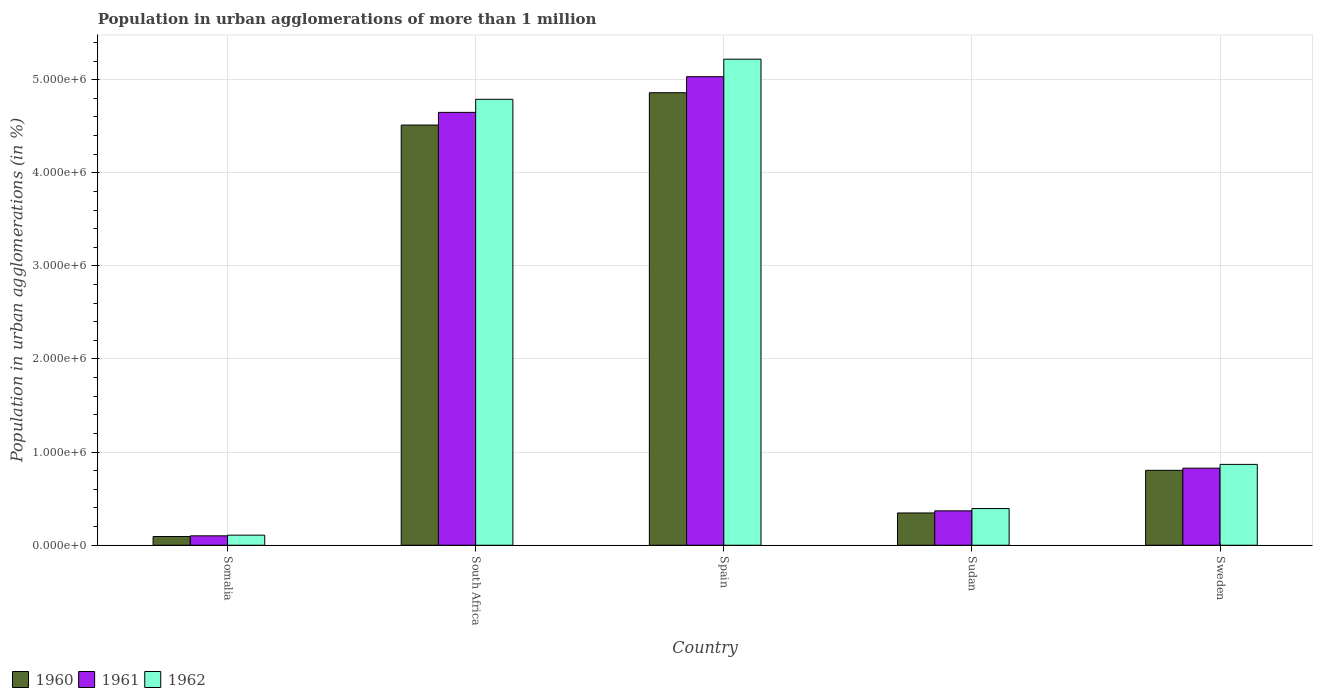How many different coloured bars are there?
Your answer should be compact. 3. Are the number of bars on each tick of the X-axis equal?
Your answer should be very brief. Yes. How many bars are there on the 1st tick from the left?
Provide a short and direct response. 3. What is the label of the 1st group of bars from the left?
Make the answer very short. Somalia. In how many cases, is the number of bars for a given country not equal to the number of legend labels?
Offer a very short reply. 0. What is the population in urban agglomerations in 1962 in South Africa?
Offer a terse response. 4.79e+06. Across all countries, what is the maximum population in urban agglomerations in 1962?
Provide a succinct answer. 5.22e+06. Across all countries, what is the minimum population in urban agglomerations in 1960?
Your response must be concise. 9.39e+04. In which country was the population in urban agglomerations in 1962 minimum?
Offer a terse response. Somalia. What is the total population in urban agglomerations in 1960 in the graph?
Keep it short and to the point. 1.06e+07. What is the difference between the population in urban agglomerations in 1962 in Somalia and that in Spain?
Offer a terse response. -5.11e+06. What is the difference between the population in urban agglomerations in 1962 in Spain and the population in urban agglomerations in 1961 in Sudan?
Make the answer very short. 4.85e+06. What is the average population in urban agglomerations in 1961 per country?
Ensure brevity in your answer.  2.20e+06. What is the difference between the population in urban agglomerations of/in 1960 and population in urban agglomerations of/in 1961 in Spain?
Offer a terse response. -1.72e+05. In how many countries, is the population in urban agglomerations in 1960 greater than 4800000 %?
Make the answer very short. 1. What is the ratio of the population in urban agglomerations in 1960 in Sudan to that in Sweden?
Give a very brief answer. 0.43. What is the difference between the highest and the second highest population in urban agglomerations in 1960?
Provide a succinct answer. -3.47e+05. What is the difference between the highest and the lowest population in urban agglomerations in 1960?
Your answer should be compact. 4.77e+06. In how many countries, is the population in urban agglomerations in 1961 greater than the average population in urban agglomerations in 1961 taken over all countries?
Your answer should be very brief. 2. Is the sum of the population in urban agglomerations in 1960 in South Africa and Spain greater than the maximum population in urban agglomerations in 1962 across all countries?
Your response must be concise. Yes. What does the 3rd bar from the left in South Africa represents?
Keep it short and to the point. 1962. What does the 3rd bar from the right in Sweden represents?
Keep it short and to the point. 1960. Is it the case that in every country, the sum of the population in urban agglomerations in 1962 and population in urban agglomerations in 1961 is greater than the population in urban agglomerations in 1960?
Make the answer very short. Yes. How many bars are there?
Your response must be concise. 15. How many countries are there in the graph?
Your answer should be compact. 5. Does the graph contain any zero values?
Your answer should be very brief. No. Where does the legend appear in the graph?
Give a very brief answer. Bottom left. How are the legend labels stacked?
Ensure brevity in your answer.  Horizontal. What is the title of the graph?
Give a very brief answer. Population in urban agglomerations of more than 1 million. What is the label or title of the X-axis?
Offer a terse response. Country. What is the label or title of the Y-axis?
Make the answer very short. Population in urban agglomerations (in %). What is the Population in urban agglomerations (in %) in 1960 in Somalia?
Your answer should be compact. 9.39e+04. What is the Population in urban agglomerations (in %) of 1961 in Somalia?
Provide a succinct answer. 1.01e+05. What is the Population in urban agglomerations (in %) in 1962 in Somalia?
Provide a succinct answer. 1.08e+05. What is the Population in urban agglomerations (in %) of 1960 in South Africa?
Offer a terse response. 4.51e+06. What is the Population in urban agglomerations (in %) of 1961 in South Africa?
Give a very brief answer. 4.65e+06. What is the Population in urban agglomerations (in %) in 1962 in South Africa?
Offer a very short reply. 4.79e+06. What is the Population in urban agglomerations (in %) in 1960 in Spain?
Your response must be concise. 4.86e+06. What is the Population in urban agglomerations (in %) of 1961 in Spain?
Your answer should be very brief. 5.03e+06. What is the Population in urban agglomerations (in %) of 1962 in Spain?
Your answer should be compact. 5.22e+06. What is the Population in urban agglomerations (in %) in 1960 in Sudan?
Provide a short and direct response. 3.47e+05. What is the Population in urban agglomerations (in %) in 1961 in Sudan?
Your answer should be very brief. 3.69e+05. What is the Population in urban agglomerations (in %) of 1962 in Sudan?
Offer a very short reply. 3.94e+05. What is the Population in urban agglomerations (in %) in 1960 in Sweden?
Give a very brief answer. 8.05e+05. What is the Population in urban agglomerations (in %) of 1961 in Sweden?
Offer a terse response. 8.27e+05. What is the Population in urban agglomerations (in %) in 1962 in Sweden?
Make the answer very short. 8.68e+05. Across all countries, what is the maximum Population in urban agglomerations (in %) in 1960?
Your response must be concise. 4.86e+06. Across all countries, what is the maximum Population in urban agglomerations (in %) in 1961?
Your answer should be very brief. 5.03e+06. Across all countries, what is the maximum Population in urban agglomerations (in %) in 1962?
Your answer should be compact. 5.22e+06. Across all countries, what is the minimum Population in urban agglomerations (in %) of 1960?
Your answer should be very brief. 9.39e+04. Across all countries, what is the minimum Population in urban agglomerations (in %) of 1961?
Your response must be concise. 1.01e+05. Across all countries, what is the minimum Population in urban agglomerations (in %) of 1962?
Keep it short and to the point. 1.08e+05. What is the total Population in urban agglomerations (in %) in 1960 in the graph?
Offer a very short reply. 1.06e+07. What is the total Population in urban agglomerations (in %) in 1961 in the graph?
Offer a terse response. 1.10e+07. What is the total Population in urban agglomerations (in %) of 1962 in the graph?
Ensure brevity in your answer.  1.14e+07. What is the difference between the Population in urban agglomerations (in %) of 1960 in Somalia and that in South Africa?
Make the answer very short. -4.42e+06. What is the difference between the Population in urban agglomerations (in %) in 1961 in Somalia and that in South Africa?
Ensure brevity in your answer.  -4.55e+06. What is the difference between the Population in urban agglomerations (in %) of 1962 in Somalia and that in South Africa?
Make the answer very short. -4.68e+06. What is the difference between the Population in urban agglomerations (in %) in 1960 in Somalia and that in Spain?
Offer a terse response. -4.77e+06. What is the difference between the Population in urban agglomerations (in %) in 1961 in Somalia and that in Spain?
Provide a succinct answer. -4.93e+06. What is the difference between the Population in urban agglomerations (in %) of 1962 in Somalia and that in Spain?
Give a very brief answer. -5.11e+06. What is the difference between the Population in urban agglomerations (in %) of 1960 in Somalia and that in Sudan?
Offer a terse response. -2.53e+05. What is the difference between the Population in urban agglomerations (in %) in 1961 in Somalia and that in Sudan?
Your response must be concise. -2.69e+05. What is the difference between the Population in urban agglomerations (in %) of 1962 in Somalia and that in Sudan?
Your response must be concise. -2.86e+05. What is the difference between the Population in urban agglomerations (in %) of 1960 in Somalia and that in Sweden?
Your response must be concise. -7.11e+05. What is the difference between the Population in urban agglomerations (in %) in 1961 in Somalia and that in Sweden?
Offer a very short reply. -7.27e+05. What is the difference between the Population in urban agglomerations (in %) of 1962 in Somalia and that in Sweden?
Your answer should be very brief. -7.60e+05. What is the difference between the Population in urban agglomerations (in %) in 1960 in South Africa and that in Spain?
Offer a terse response. -3.47e+05. What is the difference between the Population in urban agglomerations (in %) of 1961 in South Africa and that in Spain?
Keep it short and to the point. -3.83e+05. What is the difference between the Population in urban agglomerations (in %) of 1962 in South Africa and that in Spain?
Give a very brief answer. -4.31e+05. What is the difference between the Population in urban agglomerations (in %) in 1960 in South Africa and that in Sudan?
Your response must be concise. 4.17e+06. What is the difference between the Population in urban agglomerations (in %) of 1961 in South Africa and that in Sudan?
Your answer should be compact. 4.28e+06. What is the difference between the Population in urban agglomerations (in %) in 1962 in South Africa and that in Sudan?
Give a very brief answer. 4.39e+06. What is the difference between the Population in urban agglomerations (in %) of 1960 in South Africa and that in Sweden?
Make the answer very short. 3.71e+06. What is the difference between the Population in urban agglomerations (in %) in 1961 in South Africa and that in Sweden?
Your answer should be compact. 3.82e+06. What is the difference between the Population in urban agglomerations (in %) of 1962 in South Africa and that in Sweden?
Provide a short and direct response. 3.92e+06. What is the difference between the Population in urban agglomerations (in %) in 1960 in Spain and that in Sudan?
Provide a short and direct response. 4.51e+06. What is the difference between the Population in urban agglomerations (in %) in 1961 in Spain and that in Sudan?
Offer a terse response. 4.66e+06. What is the difference between the Population in urban agglomerations (in %) of 1962 in Spain and that in Sudan?
Your answer should be compact. 4.83e+06. What is the difference between the Population in urban agglomerations (in %) in 1960 in Spain and that in Sweden?
Offer a terse response. 4.05e+06. What is the difference between the Population in urban agglomerations (in %) of 1961 in Spain and that in Sweden?
Provide a short and direct response. 4.20e+06. What is the difference between the Population in urban agglomerations (in %) of 1962 in Spain and that in Sweden?
Make the answer very short. 4.35e+06. What is the difference between the Population in urban agglomerations (in %) in 1960 in Sudan and that in Sweden?
Keep it short and to the point. -4.58e+05. What is the difference between the Population in urban agglomerations (in %) in 1961 in Sudan and that in Sweden?
Your answer should be compact. -4.58e+05. What is the difference between the Population in urban agglomerations (in %) in 1962 in Sudan and that in Sweden?
Your answer should be very brief. -4.74e+05. What is the difference between the Population in urban agglomerations (in %) in 1960 in Somalia and the Population in urban agglomerations (in %) in 1961 in South Africa?
Your answer should be very brief. -4.55e+06. What is the difference between the Population in urban agglomerations (in %) of 1960 in Somalia and the Population in urban agglomerations (in %) of 1962 in South Africa?
Provide a short and direct response. -4.69e+06. What is the difference between the Population in urban agglomerations (in %) of 1961 in Somalia and the Population in urban agglomerations (in %) of 1962 in South Africa?
Provide a short and direct response. -4.69e+06. What is the difference between the Population in urban agglomerations (in %) in 1960 in Somalia and the Population in urban agglomerations (in %) in 1961 in Spain?
Your response must be concise. -4.94e+06. What is the difference between the Population in urban agglomerations (in %) of 1960 in Somalia and the Population in urban agglomerations (in %) of 1962 in Spain?
Provide a succinct answer. -5.13e+06. What is the difference between the Population in urban agglomerations (in %) of 1961 in Somalia and the Population in urban agglomerations (in %) of 1962 in Spain?
Your answer should be very brief. -5.12e+06. What is the difference between the Population in urban agglomerations (in %) of 1960 in Somalia and the Population in urban agglomerations (in %) of 1961 in Sudan?
Ensure brevity in your answer.  -2.76e+05. What is the difference between the Population in urban agglomerations (in %) in 1960 in Somalia and the Population in urban agglomerations (in %) in 1962 in Sudan?
Offer a very short reply. -3.00e+05. What is the difference between the Population in urban agglomerations (in %) of 1961 in Somalia and the Population in urban agglomerations (in %) of 1962 in Sudan?
Make the answer very short. -2.93e+05. What is the difference between the Population in urban agglomerations (in %) of 1960 in Somalia and the Population in urban agglomerations (in %) of 1961 in Sweden?
Offer a very short reply. -7.34e+05. What is the difference between the Population in urban agglomerations (in %) in 1960 in Somalia and the Population in urban agglomerations (in %) in 1962 in Sweden?
Offer a very short reply. -7.74e+05. What is the difference between the Population in urban agglomerations (in %) in 1961 in Somalia and the Population in urban agglomerations (in %) in 1962 in Sweden?
Offer a terse response. -7.67e+05. What is the difference between the Population in urban agglomerations (in %) of 1960 in South Africa and the Population in urban agglomerations (in %) of 1961 in Spain?
Provide a short and direct response. -5.19e+05. What is the difference between the Population in urban agglomerations (in %) in 1960 in South Africa and the Population in urban agglomerations (in %) in 1962 in Spain?
Your answer should be compact. -7.07e+05. What is the difference between the Population in urban agglomerations (in %) of 1961 in South Africa and the Population in urban agglomerations (in %) of 1962 in Spain?
Your answer should be compact. -5.71e+05. What is the difference between the Population in urban agglomerations (in %) of 1960 in South Africa and the Population in urban agglomerations (in %) of 1961 in Sudan?
Offer a very short reply. 4.14e+06. What is the difference between the Population in urban agglomerations (in %) in 1960 in South Africa and the Population in urban agglomerations (in %) in 1962 in Sudan?
Your answer should be compact. 4.12e+06. What is the difference between the Population in urban agglomerations (in %) of 1961 in South Africa and the Population in urban agglomerations (in %) of 1962 in Sudan?
Give a very brief answer. 4.25e+06. What is the difference between the Population in urban agglomerations (in %) of 1960 in South Africa and the Population in urban agglomerations (in %) of 1961 in Sweden?
Your answer should be compact. 3.68e+06. What is the difference between the Population in urban agglomerations (in %) in 1960 in South Africa and the Population in urban agglomerations (in %) in 1962 in Sweden?
Offer a very short reply. 3.64e+06. What is the difference between the Population in urban agglomerations (in %) in 1961 in South Africa and the Population in urban agglomerations (in %) in 1962 in Sweden?
Your answer should be compact. 3.78e+06. What is the difference between the Population in urban agglomerations (in %) in 1960 in Spain and the Population in urban agglomerations (in %) in 1961 in Sudan?
Your response must be concise. 4.49e+06. What is the difference between the Population in urban agglomerations (in %) of 1960 in Spain and the Population in urban agglomerations (in %) of 1962 in Sudan?
Your response must be concise. 4.47e+06. What is the difference between the Population in urban agglomerations (in %) of 1961 in Spain and the Population in urban agglomerations (in %) of 1962 in Sudan?
Provide a short and direct response. 4.64e+06. What is the difference between the Population in urban agglomerations (in %) in 1960 in Spain and the Population in urban agglomerations (in %) in 1961 in Sweden?
Offer a very short reply. 4.03e+06. What is the difference between the Population in urban agglomerations (in %) in 1960 in Spain and the Population in urban agglomerations (in %) in 1962 in Sweden?
Offer a terse response. 3.99e+06. What is the difference between the Population in urban agglomerations (in %) in 1961 in Spain and the Population in urban agglomerations (in %) in 1962 in Sweden?
Offer a very short reply. 4.16e+06. What is the difference between the Population in urban agglomerations (in %) in 1960 in Sudan and the Population in urban agglomerations (in %) in 1961 in Sweden?
Ensure brevity in your answer.  -4.81e+05. What is the difference between the Population in urban agglomerations (in %) in 1960 in Sudan and the Population in urban agglomerations (in %) in 1962 in Sweden?
Your response must be concise. -5.22e+05. What is the difference between the Population in urban agglomerations (in %) in 1961 in Sudan and the Population in urban agglomerations (in %) in 1962 in Sweden?
Provide a short and direct response. -4.99e+05. What is the average Population in urban agglomerations (in %) of 1960 per country?
Offer a very short reply. 2.12e+06. What is the average Population in urban agglomerations (in %) of 1961 per country?
Keep it short and to the point. 2.20e+06. What is the average Population in urban agglomerations (in %) in 1962 per country?
Keep it short and to the point. 2.28e+06. What is the difference between the Population in urban agglomerations (in %) in 1960 and Population in urban agglomerations (in %) in 1961 in Somalia?
Ensure brevity in your answer.  -6956. What is the difference between the Population in urban agglomerations (in %) in 1960 and Population in urban agglomerations (in %) in 1962 in Somalia?
Ensure brevity in your answer.  -1.44e+04. What is the difference between the Population in urban agglomerations (in %) in 1961 and Population in urban agglomerations (in %) in 1962 in Somalia?
Keep it short and to the point. -7482. What is the difference between the Population in urban agglomerations (in %) in 1960 and Population in urban agglomerations (in %) in 1961 in South Africa?
Offer a terse response. -1.36e+05. What is the difference between the Population in urban agglomerations (in %) of 1960 and Population in urban agglomerations (in %) of 1962 in South Africa?
Provide a short and direct response. -2.76e+05. What is the difference between the Population in urban agglomerations (in %) in 1961 and Population in urban agglomerations (in %) in 1962 in South Africa?
Keep it short and to the point. -1.40e+05. What is the difference between the Population in urban agglomerations (in %) in 1960 and Population in urban agglomerations (in %) in 1961 in Spain?
Offer a terse response. -1.72e+05. What is the difference between the Population in urban agglomerations (in %) of 1960 and Population in urban agglomerations (in %) of 1962 in Spain?
Your answer should be compact. -3.60e+05. What is the difference between the Population in urban agglomerations (in %) in 1961 and Population in urban agglomerations (in %) in 1962 in Spain?
Your answer should be compact. -1.88e+05. What is the difference between the Population in urban agglomerations (in %) of 1960 and Population in urban agglomerations (in %) of 1961 in Sudan?
Your answer should be very brief. -2.29e+04. What is the difference between the Population in urban agglomerations (in %) of 1960 and Population in urban agglomerations (in %) of 1962 in Sudan?
Make the answer very short. -4.73e+04. What is the difference between the Population in urban agglomerations (in %) of 1961 and Population in urban agglomerations (in %) of 1962 in Sudan?
Provide a succinct answer. -2.44e+04. What is the difference between the Population in urban agglomerations (in %) in 1960 and Population in urban agglomerations (in %) in 1961 in Sweden?
Make the answer very short. -2.29e+04. What is the difference between the Population in urban agglomerations (in %) in 1960 and Population in urban agglomerations (in %) in 1962 in Sweden?
Keep it short and to the point. -6.36e+04. What is the difference between the Population in urban agglomerations (in %) of 1961 and Population in urban agglomerations (in %) of 1962 in Sweden?
Your response must be concise. -4.07e+04. What is the ratio of the Population in urban agglomerations (in %) in 1960 in Somalia to that in South Africa?
Provide a short and direct response. 0.02. What is the ratio of the Population in urban agglomerations (in %) of 1961 in Somalia to that in South Africa?
Offer a very short reply. 0.02. What is the ratio of the Population in urban agglomerations (in %) in 1962 in Somalia to that in South Africa?
Your answer should be compact. 0.02. What is the ratio of the Population in urban agglomerations (in %) of 1960 in Somalia to that in Spain?
Give a very brief answer. 0.02. What is the ratio of the Population in urban agglomerations (in %) of 1962 in Somalia to that in Spain?
Your answer should be compact. 0.02. What is the ratio of the Population in urban agglomerations (in %) of 1960 in Somalia to that in Sudan?
Make the answer very short. 0.27. What is the ratio of the Population in urban agglomerations (in %) of 1961 in Somalia to that in Sudan?
Offer a terse response. 0.27. What is the ratio of the Population in urban agglomerations (in %) in 1962 in Somalia to that in Sudan?
Make the answer very short. 0.28. What is the ratio of the Population in urban agglomerations (in %) of 1960 in Somalia to that in Sweden?
Provide a short and direct response. 0.12. What is the ratio of the Population in urban agglomerations (in %) of 1961 in Somalia to that in Sweden?
Your answer should be very brief. 0.12. What is the ratio of the Population in urban agglomerations (in %) of 1962 in Somalia to that in Sweden?
Your answer should be compact. 0.12. What is the ratio of the Population in urban agglomerations (in %) of 1960 in South Africa to that in Spain?
Provide a short and direct response. 0.93. What is the ratio of the Population in urban agglomerations (in %) in 1961 in South Africa to that in Spain?
Keep it short and to the point. 0.92. What is the ratio of the Population in urban agglomerations (in %) in 1962 in South Africa to that in Spain?
Your answer should be compact. 0.92. What is the ratio of the Population in urban agglomerations (in %) in 1960 in South Africa to that in Sudan?
Give a very brief answer. 13.02. What is the ratio of the Population in urban agglomerations (in %) in 1961 in South Africa to that in Sudan?
Keep it short and to the point. 12.58. What is the ratio of the Population in urban agglomerations (in %) of 1962 in South Africa to that in Sudan?
Offer a terse response. 12.16. What is the ratio of the Population in urban agglomerations (in %) of 1960 in South Africa to that in Sweden?
Your answer should be very brief. 5.61. What is the ratio of the Population in urban agglomerations (in %) in 1961 in South Africa to that in Sweden?
Make the answer very short. 5.62. What is the ratio of the Population in urban agglomerations (in %) of 1962 in South Africa to that in Sweden?
Make the answer very short. 5.52. What is the ratio of the Population in urban agglomerations (in %) of 1960 in Spain to that in Sudan?
Your answer should be compact. 14.02. What is the ratio of the Population in urban agglomerations (in %) of 1961 in Spain to that in Sudan?
Your response must be concise. 13.62. What is the ratio of the Population in urban agglomerations (in %) in 1962 in Spain to that in Sudan?
Offer a very short reply. 13.25. What is the ratio of the Population in urban agglomerations (in %) in 1960 in Spain to that in Sweden?
Ensure brevity in your answer.  6.04. What is the ratio of the Population in urban agglomerations (in %) of 1961 in Spain to that in Sweden?
Your answer should be compact. 6.08. What is the ratio of the Population in urban agglomerations (in %) in 1962 in Spain to that in Sweden?
Keep it short and to the point. 6.01. What is the ratio of the Population in urban agglomerations (in %) of 1960 in Sudan to that in Sweden?
Make the answer very short. 0.43. What is the ratio of the Population in urban agglomerations (in %) in 1961 in Sudan to that in Sweden?
Provide a succinct answer. 0.45. What is the ratio of the Population in urban agglomerations (in %) in 1962 in Sudan to that in Sweden?
Offer a terse response. 0.45. What is the difference between the highest and the second highest Population in urban agglomerations (in %) in 1960?
Ensure brevity in your answer.  3.47e+05. What is the difference between the highest and the second highest Population in urban agglomerations (in %) of 1961?
Ensure brevity in your answer.  3.83e+05. What is the difference between the highest and the second highest Population in urban agglomerations (in %) of 1962?
Provide a succinct answer. 4.31e+05. What is the difference between the highest and the lowest Population in urban agglomerations (in %) in 1960?
Keep it short and to the point. 4.77e+06. What is the difference between the highest and the lowest Population in urban agglomerations (in %) of 1961?
Provide a succinct answer. 4.93e+06. What is the difference between the highest and the lowest Population in urban agglomerations (in %) in 1962?
Your response must be concise. 5.11e+06. 